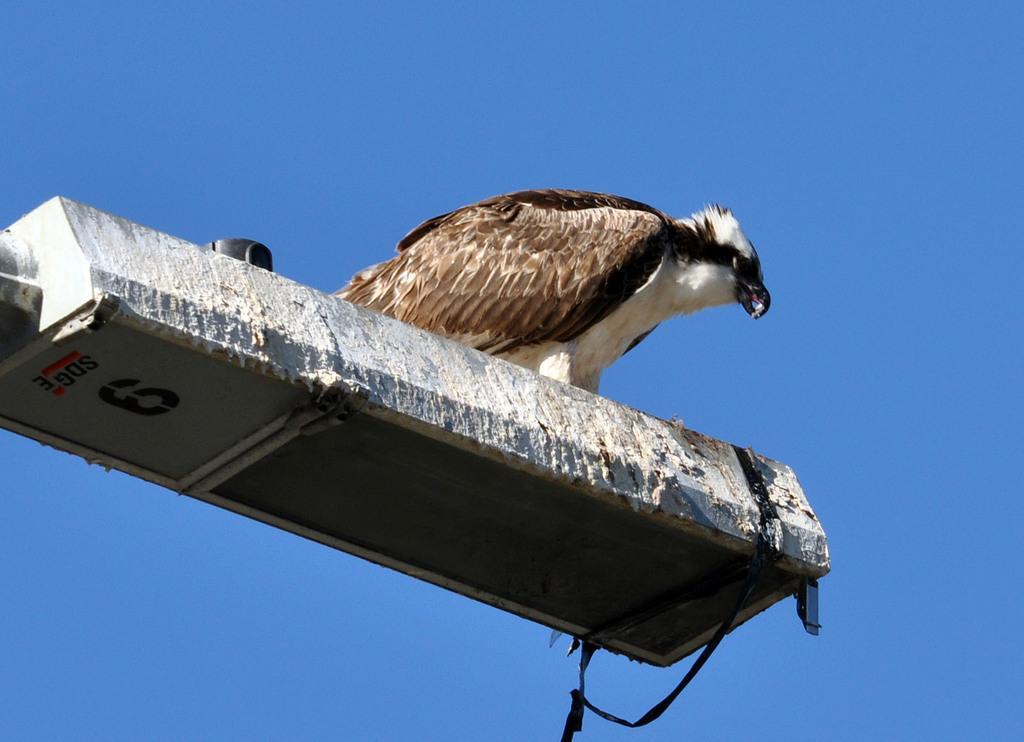Can you describe this image briefly? In this image there is a bird on the object. And the background is colored. 